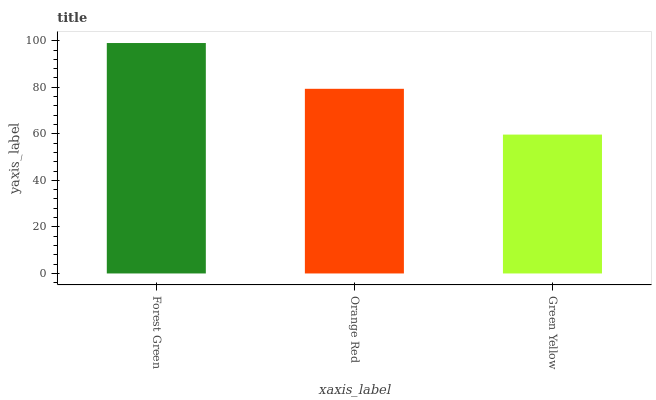Is Green Yellow the minimum?
Answer yes or no. Yes. Is Forest Green the maximum?
Answer yes or no. Yes. Is Orange Red the minimum?
Answer yes or no. No. Is Orange Red the maximum?
Answer yes or no. No. Is Forest Green greater than Orange Red?
Answer yes or no. Yes. Is Orange Red less than Forest Green?
Answer yes or no. Yes. Is Orange Red greater than Forest Green?
Answer yes or no. No. Is Forest Green less than Orange Red?
Answer yes or no. No. Is Orange Red the high median?
Answer yes or no. Yes. Is Orange Red the low median?
Answer yes or no. Yes. Is Forest Green the high median?
Answer yes or no. No. Is Forest Green the low median?
Answer yes or no. No. 